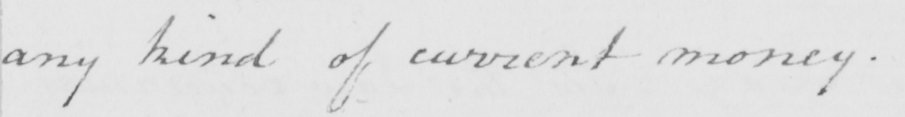Can you tell me what this handwritten text says? any kind of current money . 